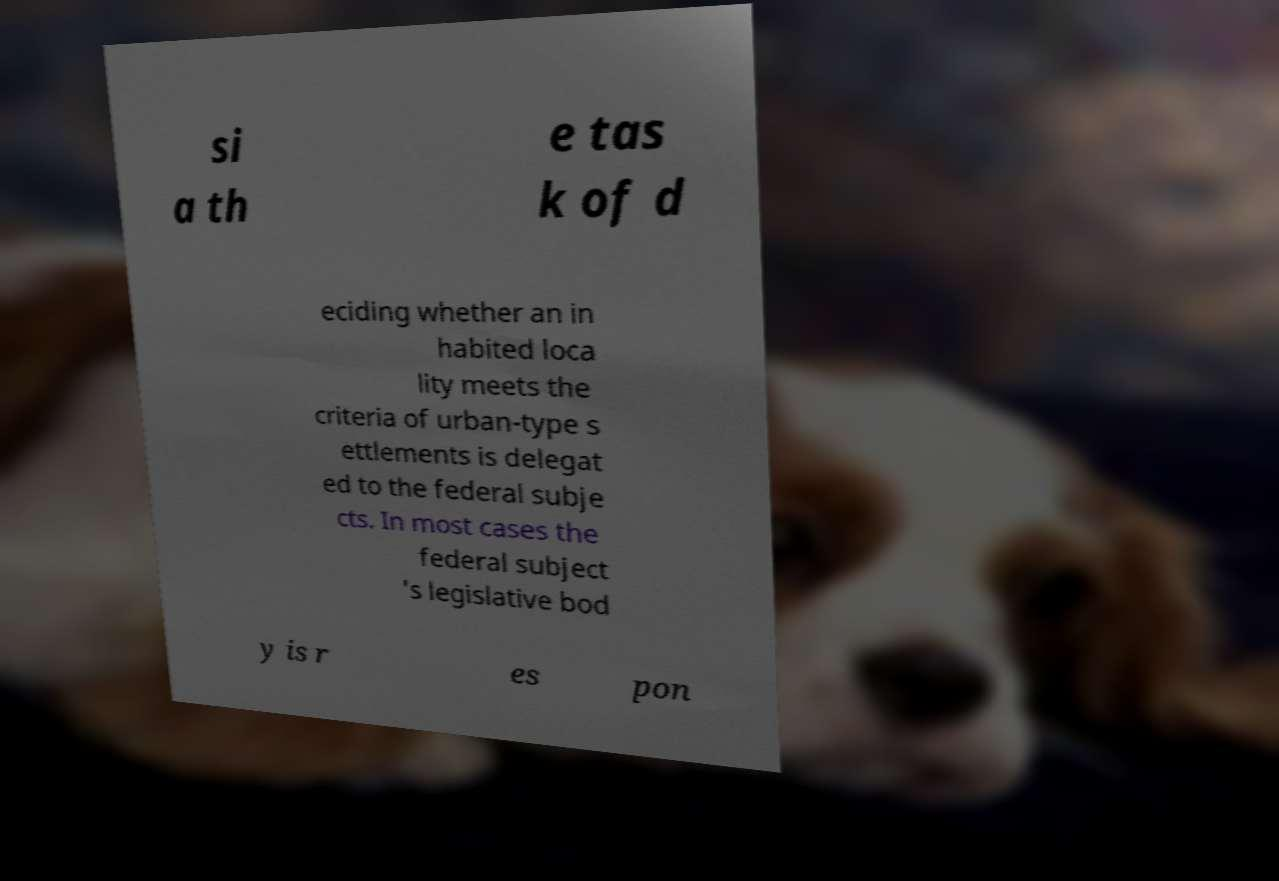I need the written content from this picture converted into text. Can you do that? si a th e tas k of d eciding whether an in habited loca lity meets the criteria of urban-type s ettlements is delegat ed to the federal subje cts. In most cases the federal subject 's legislative bod y is r es pon 